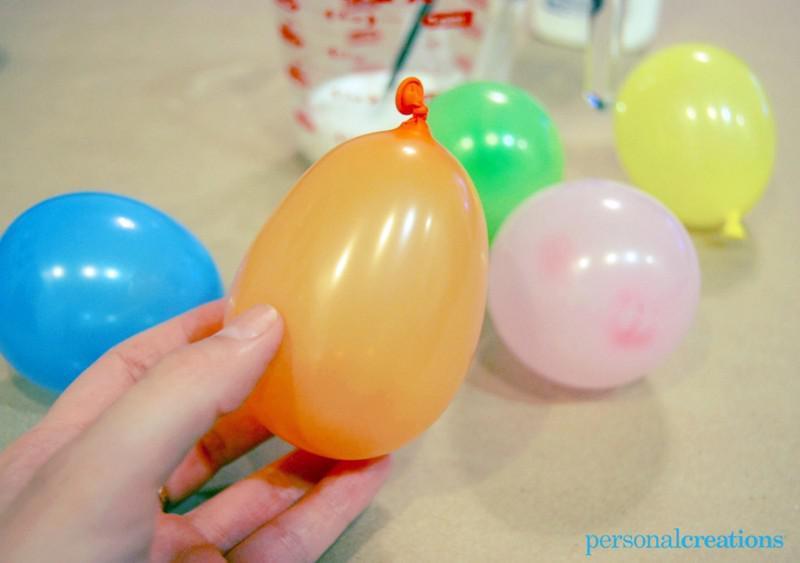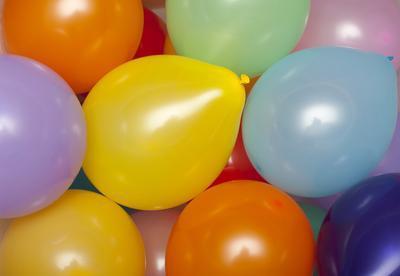The first image is the image on the left, the second image is the image on the right. For the images displayed, is the sentence "Some balloons have helium in them." factually correct? Answer yes or no. No. The first image is the image on the left, the second image is the image on the right. For the images shown, is this caption "Several balloons are in the air in the left image, and at least a dozen balloons are in a container with sides in the right image." true? Answer yes or no. No. 